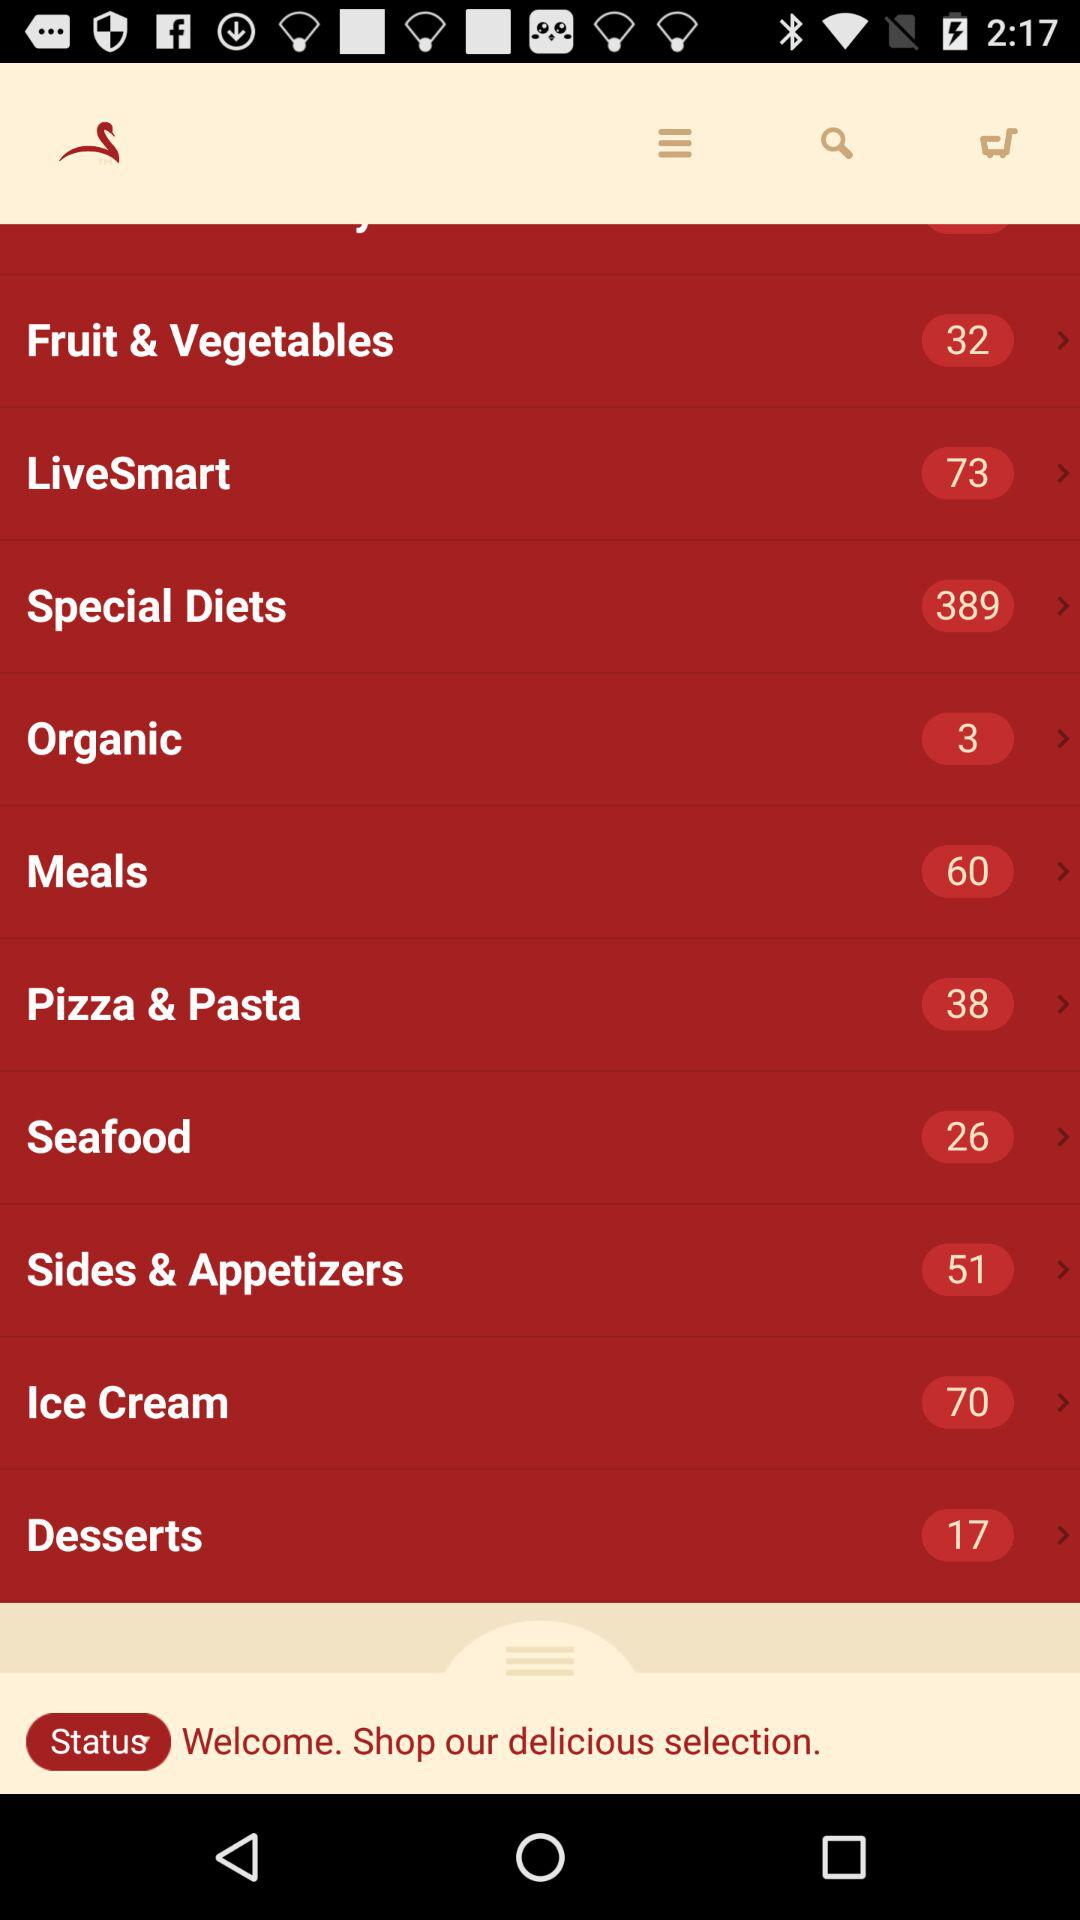How many items are in the cart?
When the provided information is insufficient, respond with <no answer>. <no answer> 